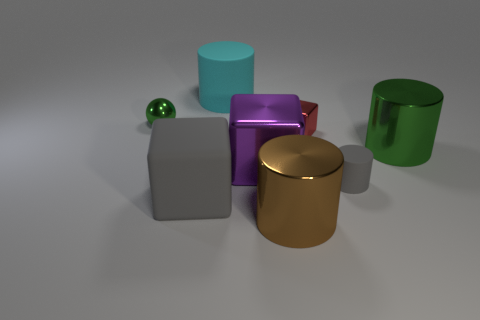Add 1 tiny balls. How many objects exist? 9 Subtract all rubber blocks. How many blocks are left? 2 Subtract all brown cylinders. How many cylinders are left? 3 Subtract all balls. How many objects are left? 7 Subtract all gray cubes. Subtract all red spheres. How many cubes are left? 2 Subtract all red cubes. How many gray cylinders are left? 1 Subtract all green metallic objects. Subtract all gray matte cylinders. How many objects are left? 5 Add 3 large cyan rubber cylinders. How many large cyan rubber cylinders are left? 4 Add 7 tiny rubber cylinders. How many tiny rubber cylinders exist? 8 Subtract 0 purple cylinders. How many objects are left? 8 